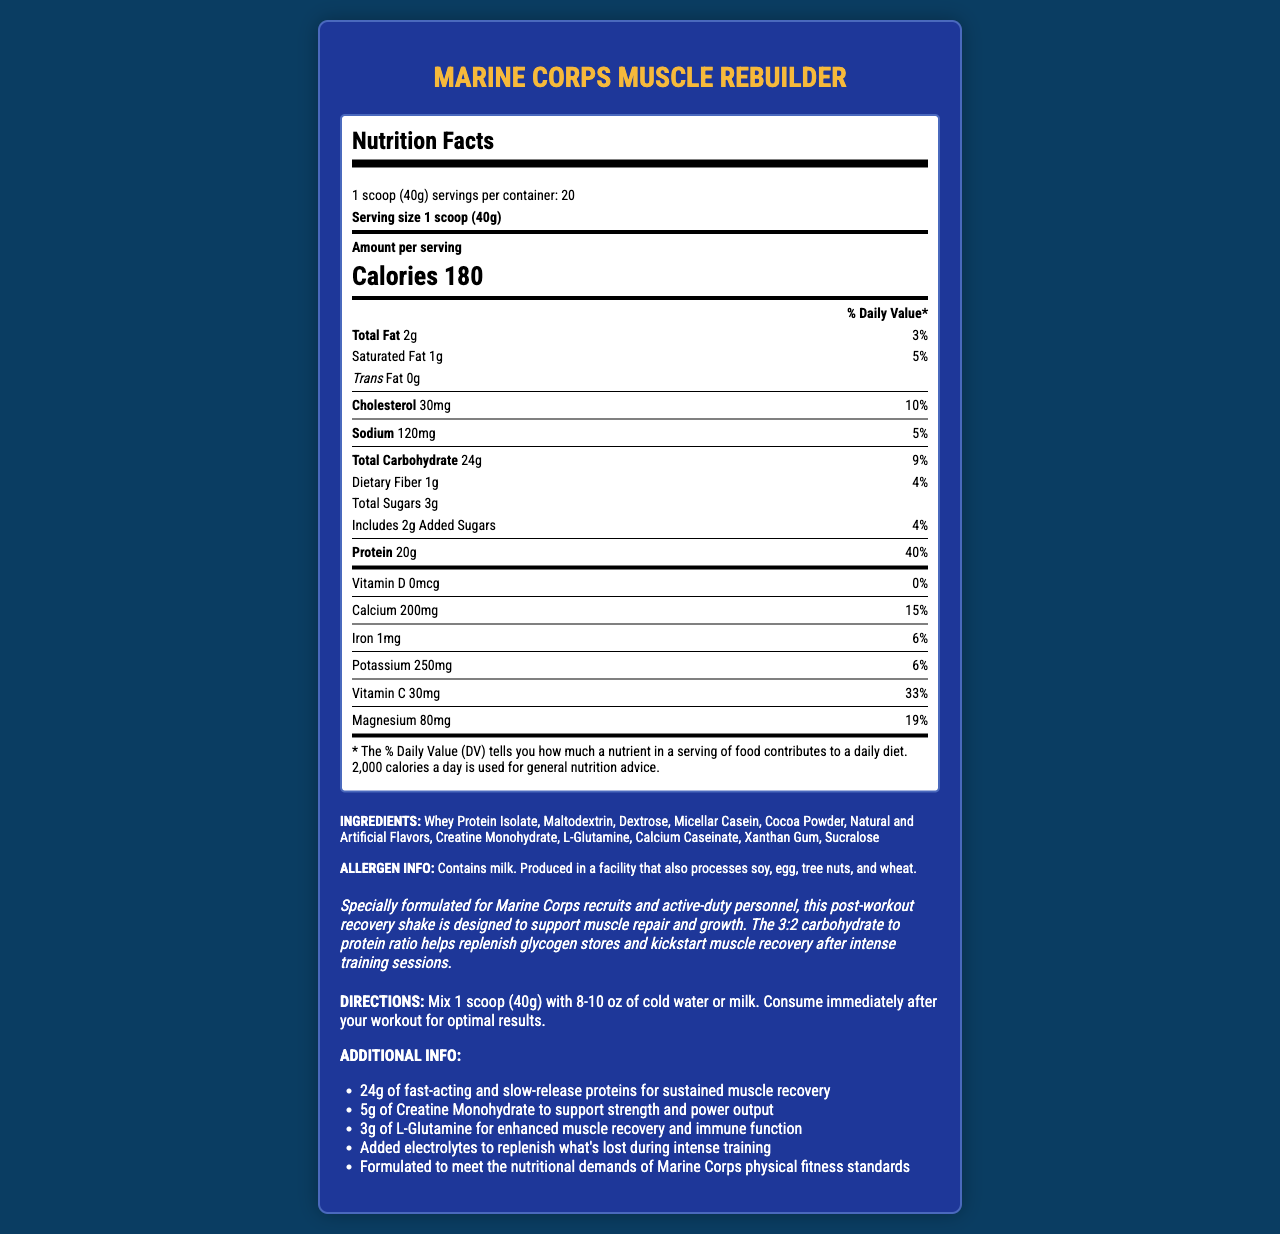what is the serving size of Marine Corps Muscle Rebuilder? The serving size is clearly mentioned at the beginning of the nutrition label as "1 scoop (40g)".
Answer: 1 scoop (40g) how many calories are in one serving? The nutrition label specifies that one serving contains 180 calories.
Answer: 180 what is the carbohydrate to protein ratio in this product? According to the product description, the carbohydrate to protein ratio is stated as 3:2.
Answer: 3:2 how many grams of protein are there per serving? The nutrition label lists the protein content as 20g per serving.
Answer: 20g what are the types of proteins included in this shake? The ingredients list mentions these three types of proteins.
Answer: Whey Protein Isolate, Micellar Casein, Calcium Caseinate how many grams of added sugars are present per serving? The nutrition label under carbohydrates indicates 2g of added sugars.
Answer: 2g which mineral has the highest daily value percentage in one serving? The daily value percentage for calcium is 15%, higher than the other listed minerals.
Answer: Calcium does the product contain any vitamin D? The nutrition label shows 0mcg for vitamin D, which is also 0% of the daily value.
Answer: No what are the main benefits of the additional ingredients such as creatine monohydrate and L-glutamine? The additional info section states that creatine monohydrate supports strength and power output, and L-Glutamine enhances muscle recovery and immune function.
Answer: Enhanced muscle recovery and supporting strength and power output how many total grams of carbohydrates are in one serving? The nutrition label lists the total carbohydrates as 24g per serving.
Answer: 24g what is the % daily value of dietary fiber in one serving? The nutrition label indicates that 1g of dietary fiber represents 4% of the daily value.
Answer: 4% what are the allergen warnings associated with this product? The allergen info section at the end of the document contains this information.
Answer: Contains milk. Produced in a facility that also processes soy, egg, tree nuts, and wheat. what is the recommended way to consume this product for optimal results? The directions section provides clear instructions for consumption.
Answer: Mix 1 scoop (40g) with 8-10 oz of cold water or milk. Consume immediately after your workout. what is the primary audience for the Marine Corps Muscle Rebuilder? The product description indicates that it is specially formulated for Marine Corps recruits and active-duty personnel.
Answer: Marine Corps recruits and active-duty personnel which of the following statements is true based on the document? A. The product contains soy as a primary ingredient. B. The product has a carbohydrate to protein ratio of 3:2. C. There are 16 grams of protein per serving. D. The product does not contain any added sugars. The product description states the carbohydrate to protein ratio is 3:2.
Answer: B how many servings of Marine Corps Muscle Rebuilder are in one container? A. 15 B. 20 C. 25 D. 30 The nutrition label mentions that there are 20 servings per container.
Answer: B is the Marine Corps Muscle Rebuilder free of added sugars? The nutrition label indicates that there are 2g of added sugars per serving.
Answer: No summarize the entire document in one sentence. This summary captures the essential information about the product's purpose, nutritional content, and instructions.
Answer: The Marine Corps Muscle Rebuilder is a post-workout recovery shake optimized for muscle repair and growth with a 3:2 carbohydrate to protein ratio, containing 20g of protein per serving, added creatine, glutamine, and electrolytes, with specific usage directions for optimal results. what is the source of carbohydrates in this shake? The nutrition label lists total carbohydrates and sugars, but it doesn't specify the exact sources of carbohydrates beyond the broad ingredient list which includes maltodextrin and dextrose.
Answer: Cannot be determined 